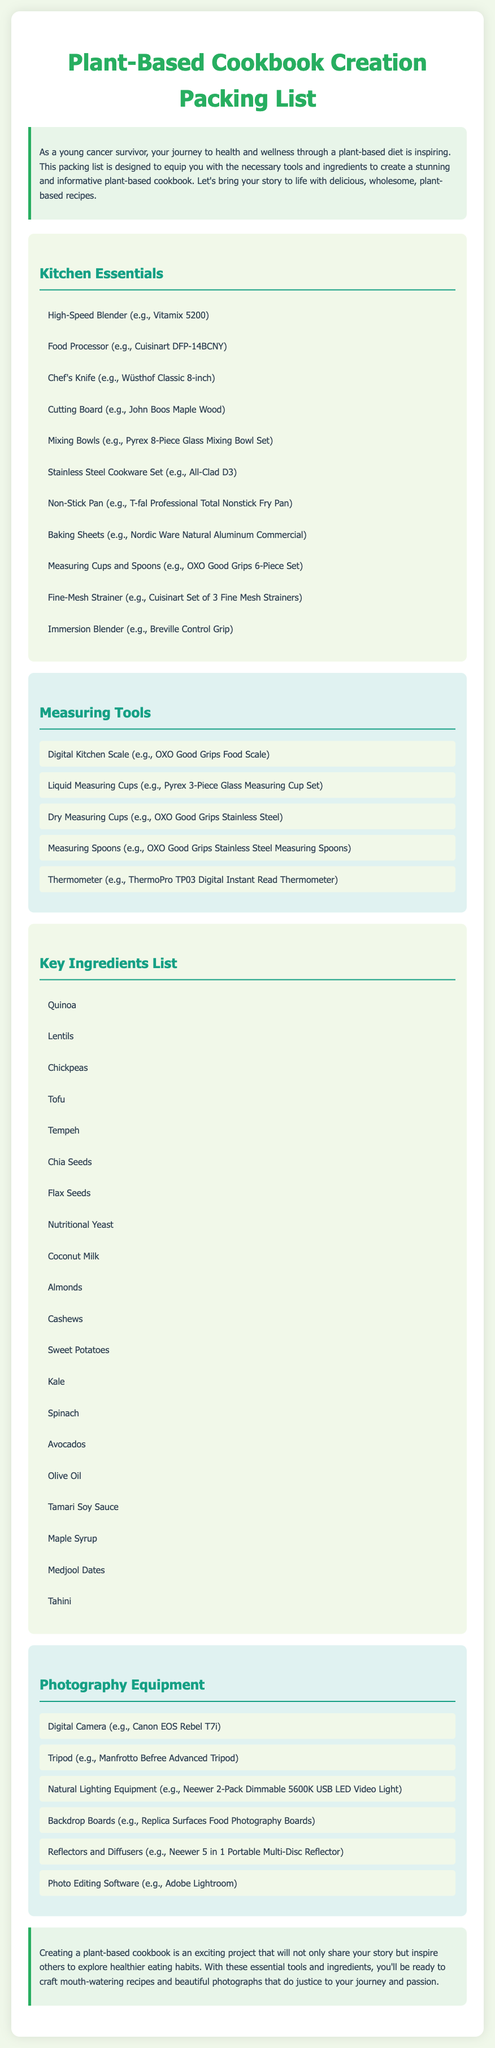what is one high-speed blender mentioned in the list? The document lists "Vitamix 5200" as a high-speed blender.
Answer: Vitamix 5200 how many measuring tools are listed? The document includes five measuring tools.
Answer: 5 name one key ingredient listed in the document. The document lists "Chickpeas" as a key ingredient.
Answer: Chickpeas what type of photography equipment is mentioned for lighting? The document mentions "Natural Lighting Equipment" for photography.
Answer: Natural Lighting Equipment which measuring tool is specified for digital measurements? The document specifies "Digital Kitchen Scale" for digital measurements.
Answer: Digital Kitchen Scale what is the primary purpose of this packing list? The packing list is designed to equip for creating a plant-based cookbook.
Answer: Plant-based cookbook how many kitchen essentials are included in the list? The list contains eleven kitchen essentials.
Answer: 11 which chef's knife brand is mentioned? The document mentions "Wüsthof Classic 8-inch" as a chef's knife brand.
Answer: Wüsthof Classic 8-inch 